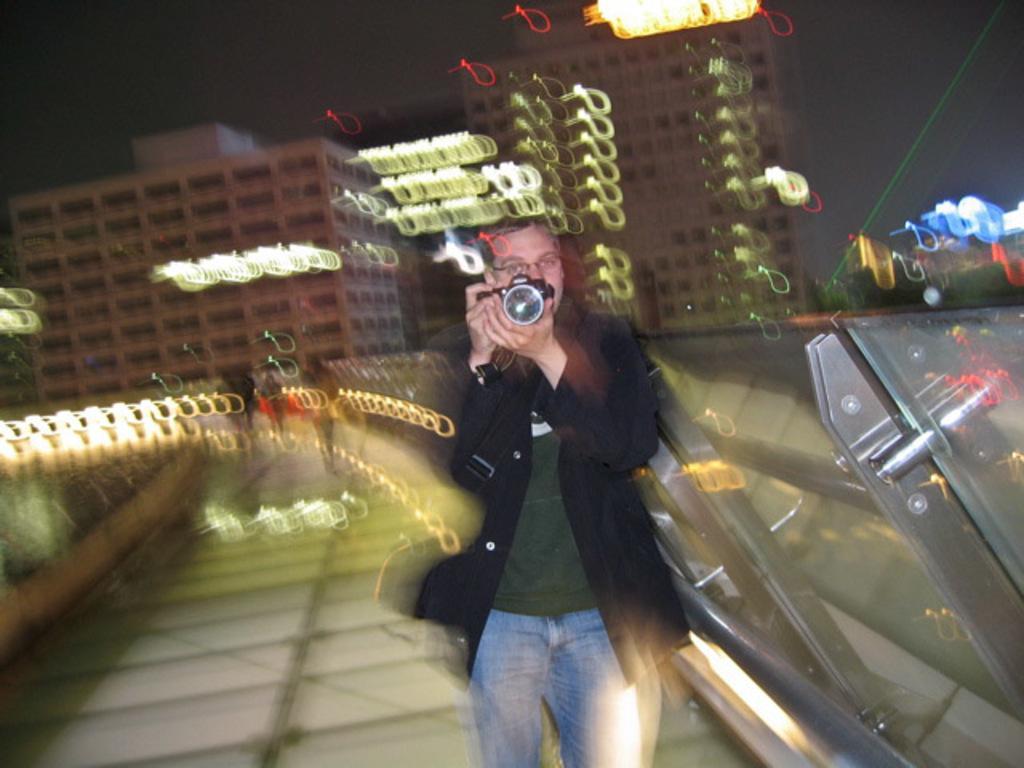Could you give a brief overview of what you see in this image? In this image we can see a man is standing. He is wearing black color coat with jeans and holding camera in his hand. Behind buildings are there. Right side of the image one fencing is present. 